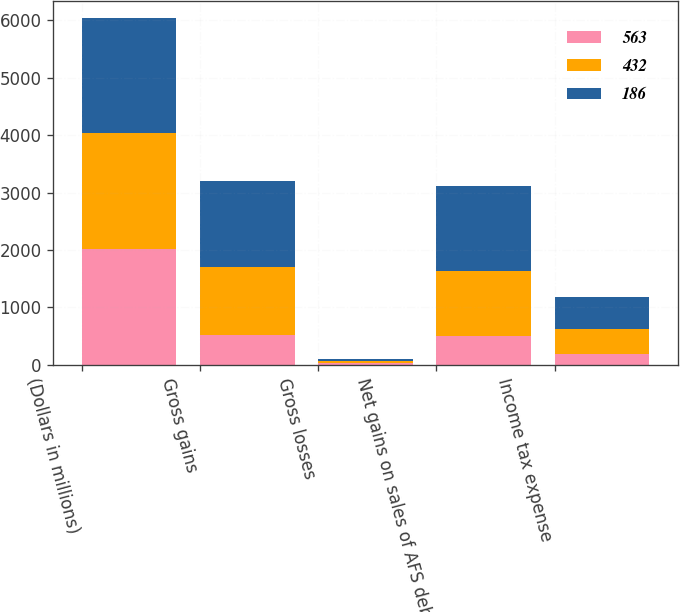Convert chart. <chart><loc_0><loc_0><loc_500><loc_500><stacked_bar_chart><ecel><fcel>(Dollars in millions)<fcel>Gross gains<fcel>Gross losses<fcel>Net gains on sales of AFS debt<fcel>Income tax expense<nl><fcel>563<fcel>2016<fcel>520<fcel>30<fcel>490<fcel>186<nl><fcel>432<fcel>2015<fcel>1174<fcel>36<fcel>1138<fcel>432<nl><fcel>186<fcel>2014<fcel>1504<fcel>23<fcel>1481<fcel>563<nl></chart> 